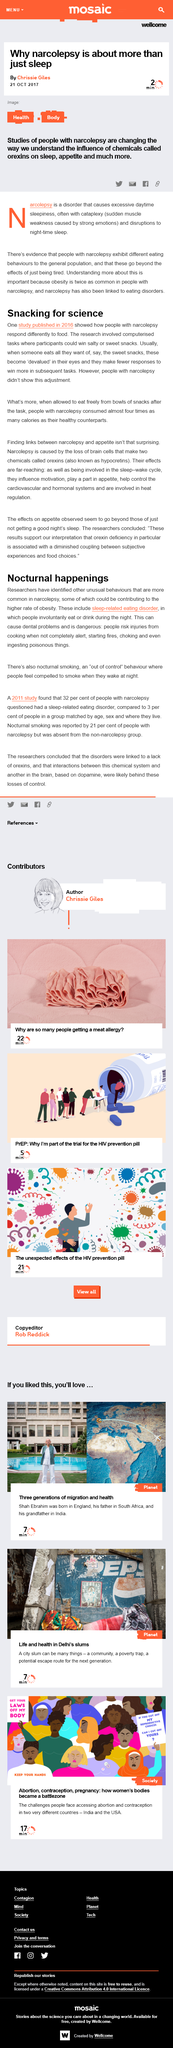Highlight a few significant elements in this photo. Sleep-related eating disorder can cause dental problems. The study was published in 2016, and it was a study that was done in the year 2016. The participants with narcolepsy did not show a reduction in response frequency after eating their preferred snack and consumed significantly more calories than the healthy participants, according to the study. Narcolepsy is a medical condition characterized by excessive daytime sleepiness and the sudden onset of sleep, often referred to as "sleep attacks," regardless of the situation or the time of day. The participants in the study have the opportunity to win either salty or sweet snacks as a prize. 